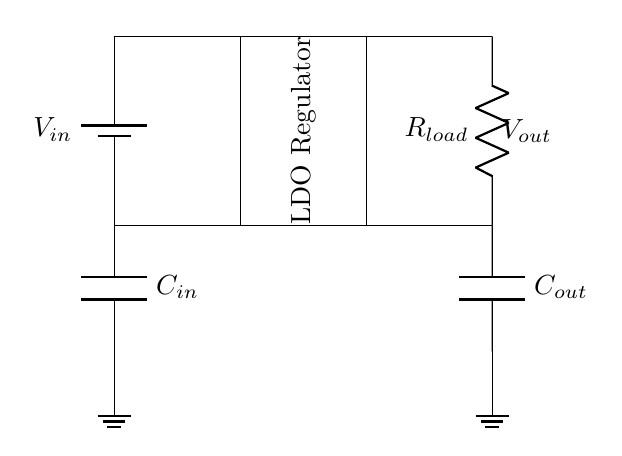What is the input voltage of this circuit? The input voltage is denoted as V-in, which is marked at the battery symbol in the circuit. Therefore, it's the supply voltage that powers the circuit.
Answer: V-in What is the component used to filter the input? The input capacitor, labeled as C-in, serves as a filter for the input voltage. It helps stabilize the voltage before it enters the LDO regulator.
Answer: C-in Which type of capacitor is used in this circuit? Both capacitors, C-in and C-out, are types of coupling capacitors. They are used for stabilizing the circuit performance by smoothing out voltage fluctuations.
Answer: Coupling How does the output voltage relate to the input voltage? The output voltage, labeled as V-out, is regulated to be lower than the input voltage V-in by the low-dropout regulator, meaning it provides a stable output voltage that is slightly less than the input.
Answer: Lower than V-in What does the load resistor represent in the circuit? The load resistor, labeled R-load, represents the total resistance of the device or circuit that is connected to the output of the LDO regulator, consuming power drawn from it.
Answer: R-load What is the purpose of the output capacitor in this design? The output capacitor, labeled C-out, is used to stabilize the output voltage by smoothing out fluctuations and providing the necessary charge during transient load changes, ensuring consistent voltage supply.
Answer: Stabilization What is a characteristic of a low-dropout regulator? A characteristic of a low-dropout regulator is its ability to maintain a stable output voltage even when the input voltage is only slightly higher than the desired output voltage, minimizing the voltage drop across the regulator.
Answer: Low voltage drop 